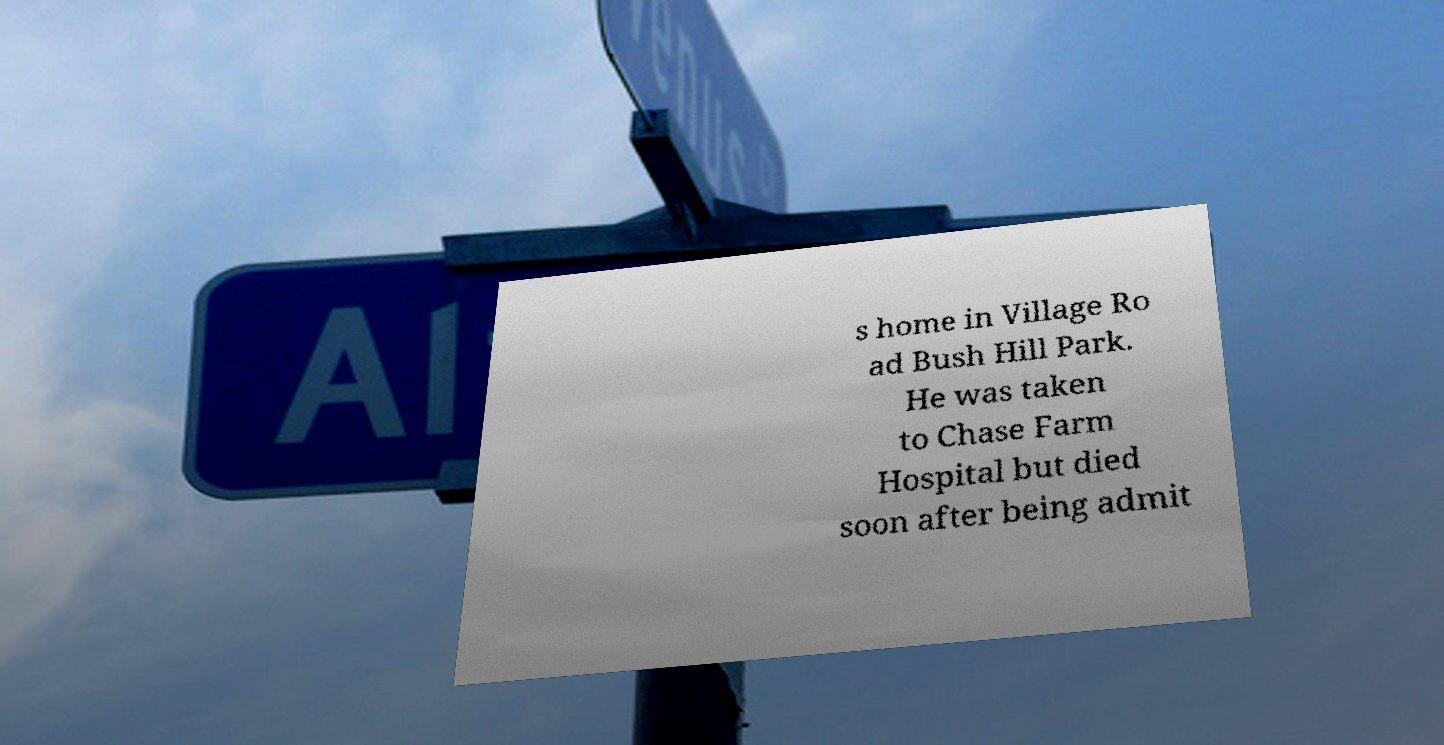Could you assist in decoding the text presented in this image and type it out clearly? s home in Village Ro ad Bush Hill Park. He was taken to Chase Farm Hospital but died soon after being admit 